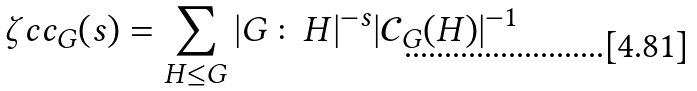Convert formula to latex. <formula><loc_0><loc_0><loc_500><loc_500>\zeta c c _ { G } ( s ) = \sum _ { H \leq G } | G \colon H | ^ { - s } | \mathcal { C } _ { G } ( H ) | ^ { - 1 }</formula> 